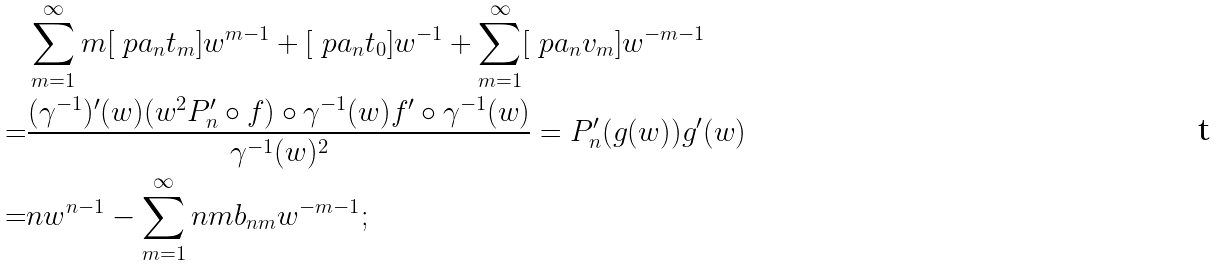<formula> <loc_0><loc_0><loc_500><loc_500>& \sum _ { m = 1 } ^ { \infty } m [ \ p a _ { n } t _ { m } ] w ^ { m - 1 } + [ \ p a _ { n } t _ { 0 } ] w ^ { - 1 } + \sum _ { m = 1 } ^ { \infty } [ \ p a _ { n } v _ { m } ] w ^ { - m - 1 } \\ = & \frac { ( \gamma ^ { - 1 } ) ^ { \prime } ( w ) ( w ^ { 2 } P _ { n } ^ { \prime } \circ f ) \circ \gamma ^ { - 1 } ( w ) f ^ { \prime } \circ \gamma ^ { - 1 } ( w ) } { \gamma ^ { - 1 } ( w ) ^ { 2 } } = P _ { n } ^ { \prime } ( g ( w ) ) g ^ { \prime } ( w ) \\ = & n w ^ { n - 1 } - \sum _ { m = 1 } ^ { \infty } n m b _ { n m } w ^ { - m - 1 } ;</formula> 